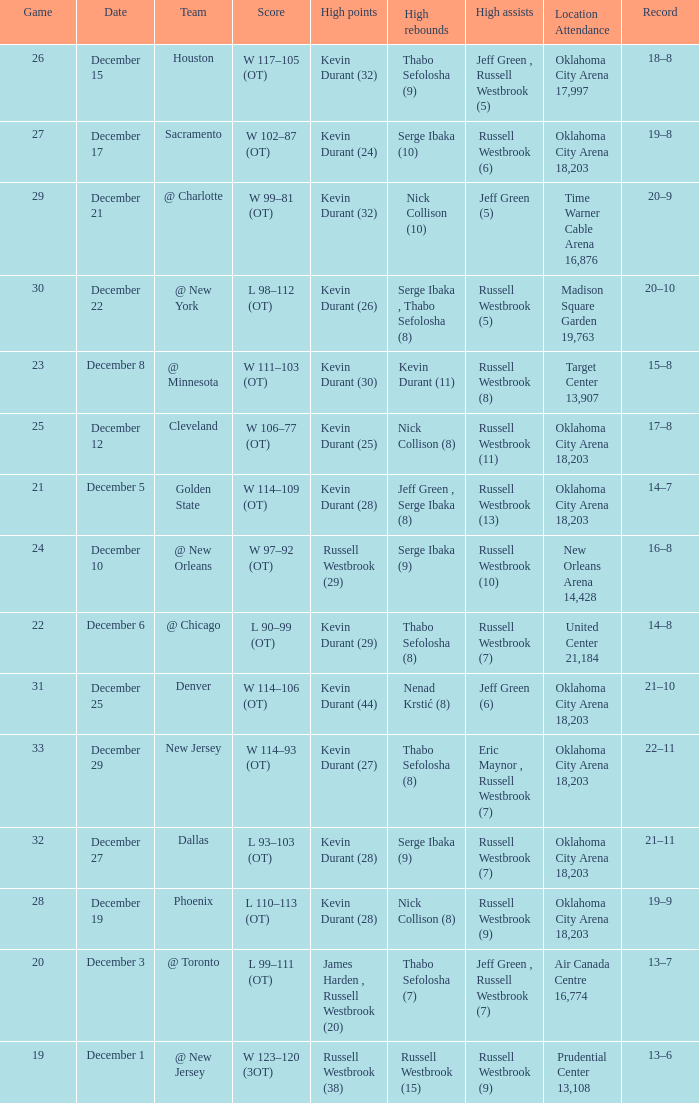What was the record on December 27? 21–11. 